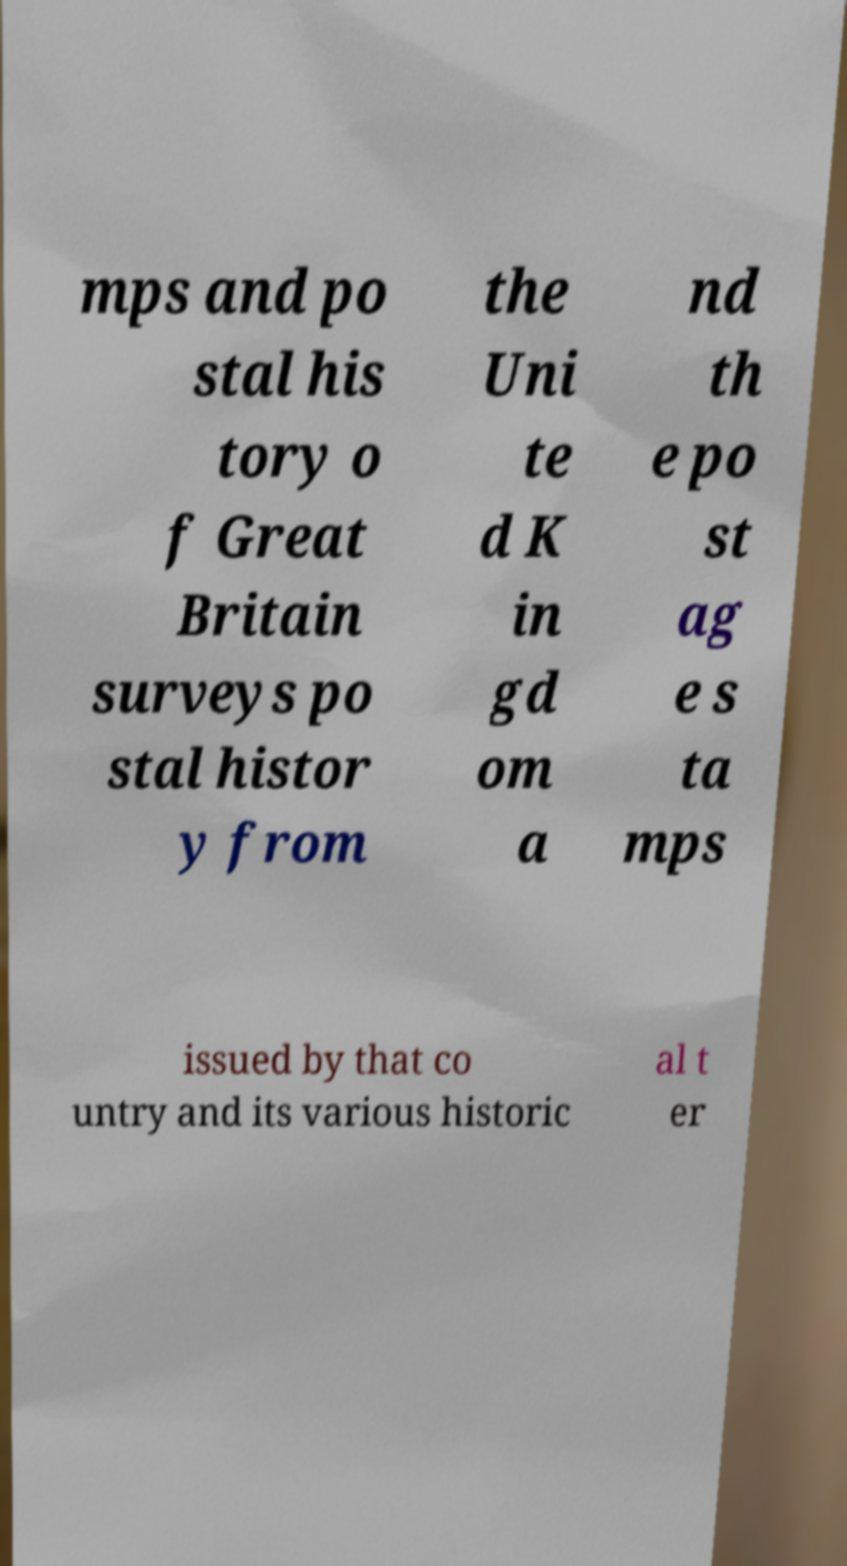For documentation purposes, I need the text within this image transcribed. Could you provide that? mps and po stal his tory o f Great Britain surveys po stal histor y from the Uni te d K in gd om a nd th e po st ag e s ta mps issued by that co untry and its various historic al t er 